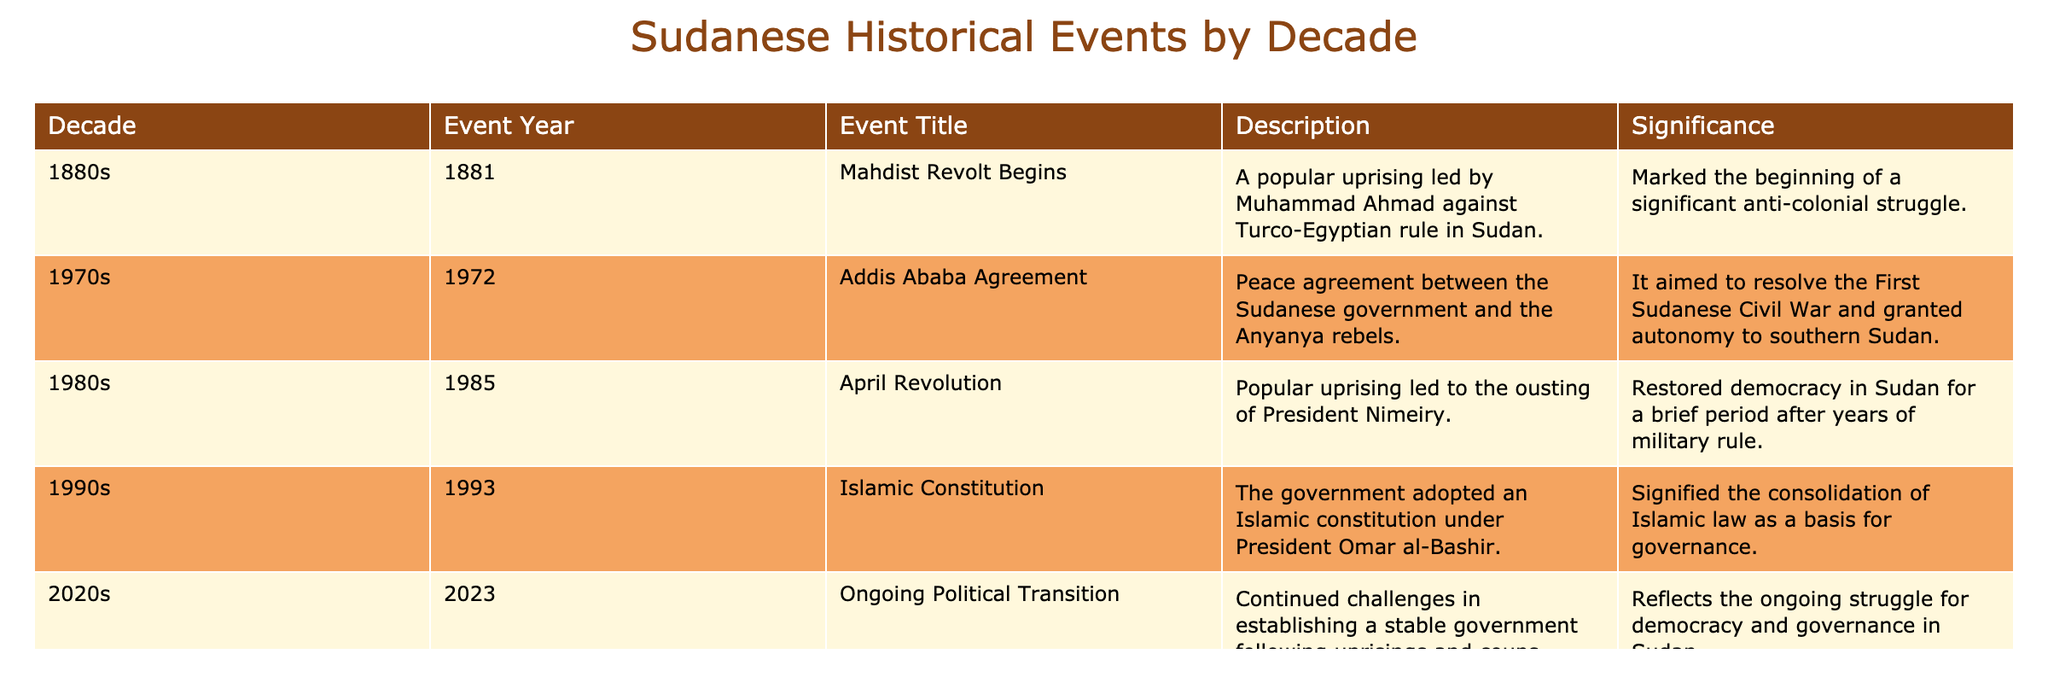What decade did the Mahdist Revolt begin? The table shows that the Mahdist Revolt began in the year 1881, which is listed under the 1880s decade.
Answer: 1880s What is the significance of the Addis Ababa Agreement? The table states that the Addis Ababa Agreement aimed to resolve the First Sudanese Civil War and granted autonomy to southern Sudan, indicating its importance in Sudanese history.
Answer: It aimed to resolve the First Sudanese Civil War Was the April Revolution successful in restoring democracy? According to the table, the April Revolution led to the ousting of President Nimeiry and restored democracy in Sudan for a brief period, suggesting a positive outcome.
Answer: Yes Which event adopted an Islamic constitution? The Islamic Constitution event, noted in the 1990s, involved the government adopting an Islamic constitution under President Omar al-Bashir.
Answer: Islamic Constitution How many decades are represented in the table? By counting the number of distinct decades listed (1880s, 1970s, 1980s, 1990s, 2020s), we find there are a total of 5 decades represented in the table.
Answer: 5 What is the difference in years between the Addis Ababa Agreement and the April Revolution? The Addis Ababa Agreement occurred in 1972 and the April Revolution occurred in 1985, so the difference is 1985 - 1972 = 13 years.
Answer: 13 years Which event is most recent according to the table? The table indicates that the ongoing political transition occurred in 2023, making it the most recent event listed.
Answer: Ongoing Political Transition Which event had the goal of establishing an Islamic law basis for governance? The Islamic Constitution, adopted in 1993, signified the consolidation of Islamic law as a basis for governance, as per the table.
Answer: Islamic Constitution Do all events listed in the table take place in the 20th century or later? The table shows that the Mahdist Revolt occurred in the 1880s, which is in the 19th century, indicating that not all events are from the 20th century or later.
Answer: No What event marked the beginning of a significant anti-colonial struggle? The Mahdist Revolt is noted for marking the beginning of a significant anti-colonial struggle in the table, which aligns with the description provided.
Answer: Mahdist Revolt 